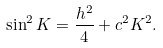<formula> <loc_0><loc_0><loc_500><loc_500>\sin ^ { 2 } K = \frac { h ^ { 2 } } { 4 } + c ^ { 2 } K ^ { 2 } .</formula> 